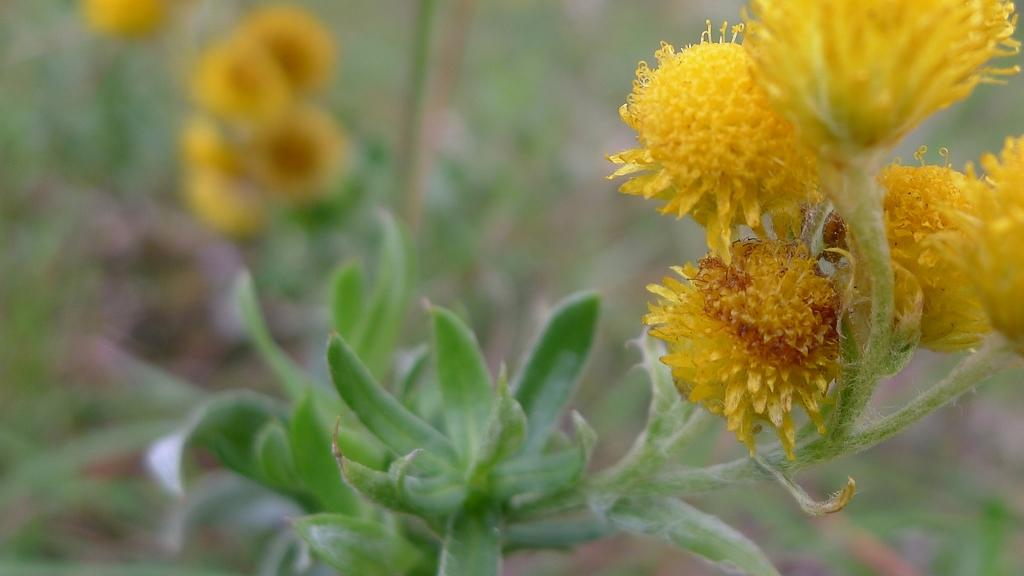What type of living organisms can be seen in the image? Plants can be seen in the image. What color are the flowers on the plants? The flowers on the plants are yellow. What type of pie is being sold on the street in the image? There is no pie or street present in the image; it only features plants with yellow flowers. 